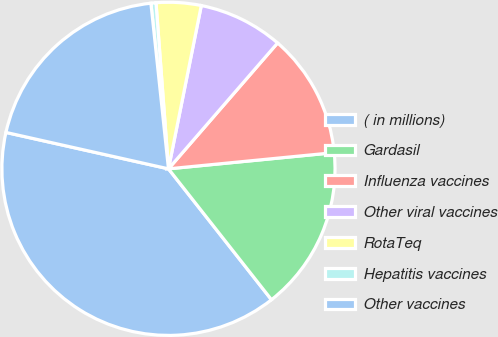Convert chart. <chart><loc_0><loc_0><loc_500><loc_500><pie_chart><fcel>( in millions)<fcel>Gardasil<fcel>Influenza vaccines<fcel>Other viral vaccines<fcel>RotaTeq<fcel>Hepatitis vaccines<fcel>Other vaccines<nl><fcel>39.12%<fcel>15.94%<fcel>12.08%<fcel>8.21%<fcel>4.35%<fcel>0.49%<fcel>19.81%<nl></chart> 